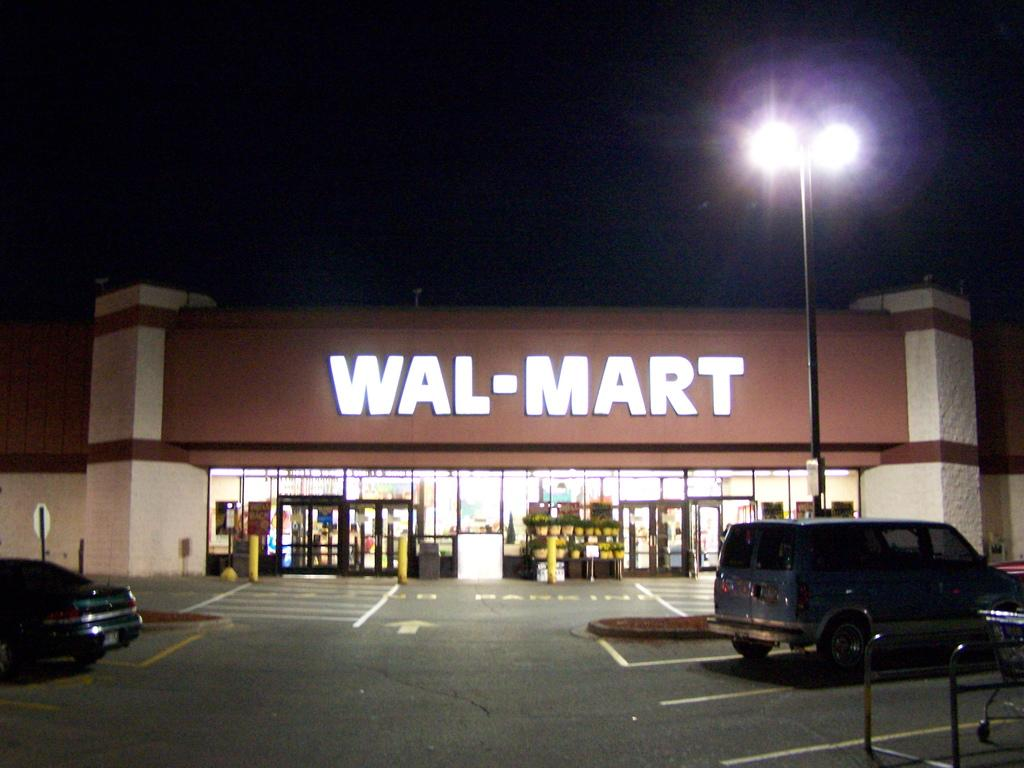<image>
Create a compact narrative representing the image presented. A Wal-Mart parking lot with a blue van parked under a light. 